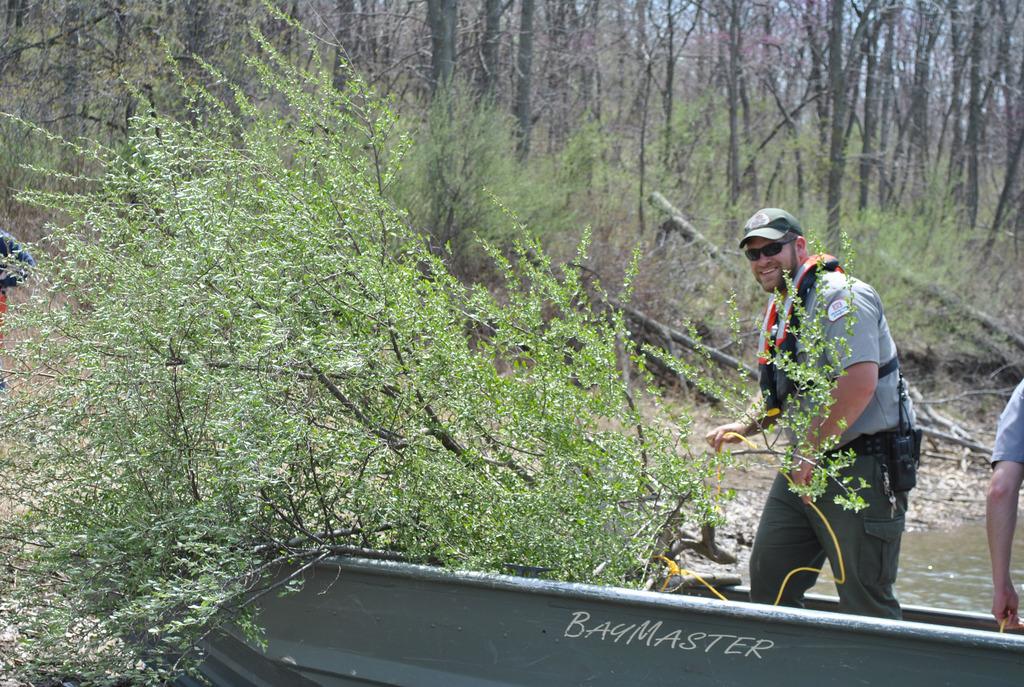What kind of boat are they on?
Your answer should be compact. Baymaster. 